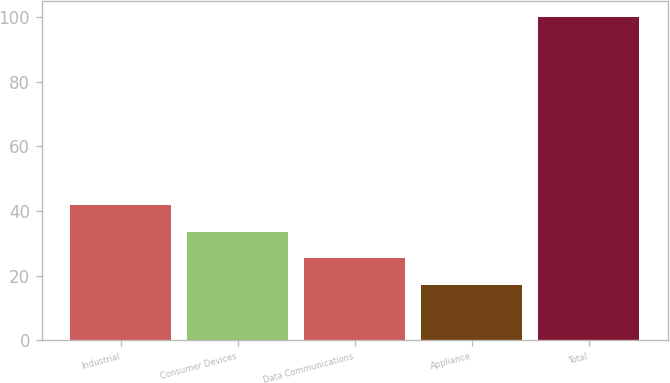Convert chart. <chart><loc_0><loc_0><loc_500><loc_500><bar_chart><fcel>Industrial<fcel>Consumer Devices<fcel>Data Communications<fcel>Appliance<fcel>Total<nl><fcel>41.9<fcel>33.6<fcel>25.3<fcel>17<fcel>100<nl></chart> 